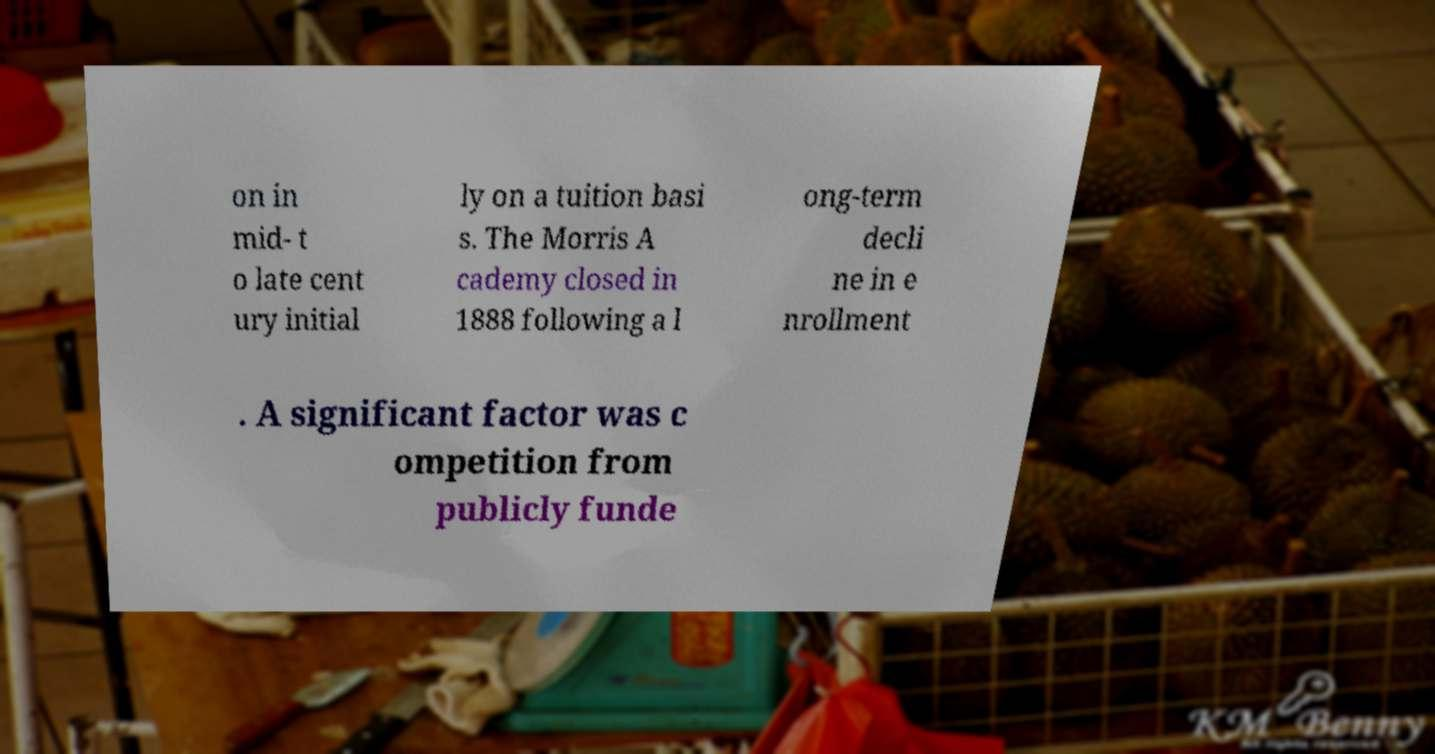Could you assist in decoding the text presented in this image and type it out clearly? on in mid- t o late cent ury initial ly on a tuition basi s. The Morris A cademy closed in 1888 following a l ong-term decli ne in e nrollment . A significant factor was c ompetition from publicly funde 